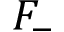<formula> <loc_0><loc_0><loc_500><loc_500>F _ { - }</formula> 